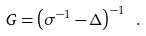<formula> <loc_0><loc_0><loc_500><loc_500>G = \left ( \sigma ^ { - 1 } - \Delta \right ) ^ { - 1 } \ .</formula> 